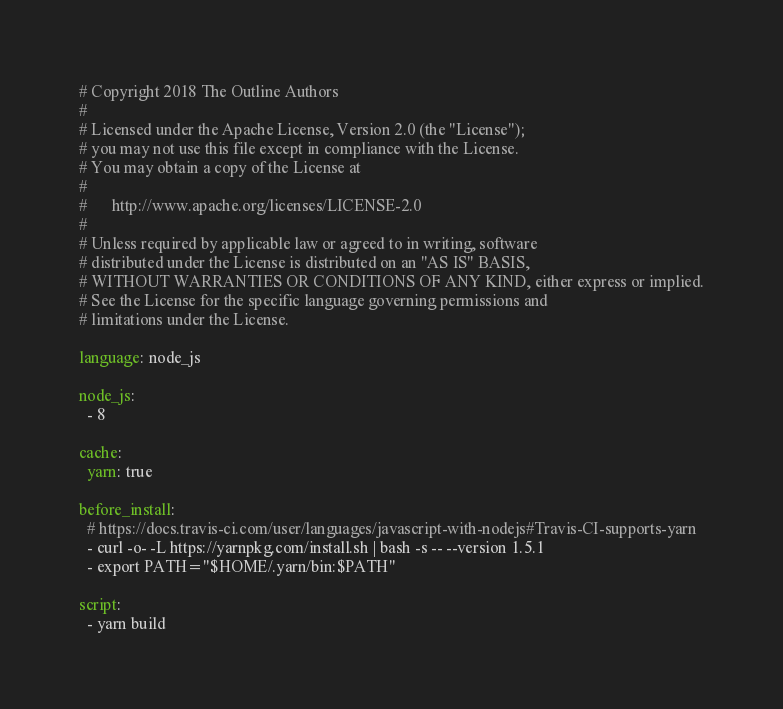Convert code to text. <code><loc_0><loc_0><loc_500><loc_500><_YAML_># Copyright 2018 The Outline Authors
#
# Licensed under the Apache License, Version 2.0 (the "License");
# you may not use this file except in compliance with the License.
# You may obtain a copy of the License at
#
#      http://www.apache.org/licenses/LICENSE-2.0
#
# Unless required by applicable law or agreed to in writing, software
# distributed under the License is distributed on an "AS IS" BASIS,
# WITHOUT WARRANTIES OR CONDITIONS OF ANY KIND, either express or implied.
# See the License for the specific language governing permissions and
# limitations under the License.

language: node_js

node_js:
  - 8

cache:
  yarn: true

before_install:
  # https://docs.travis-ci.com/user/languages/javascript-with-nodejs#Travis-CI-supports-yarn
  - curl -o- -L https://yarnpkg.com/install.sh | bash -s -- --version 1.5.1
  - export PATH="$HOME/.yarn/bin:$PATH"

script:
  - yarn build
</code> 